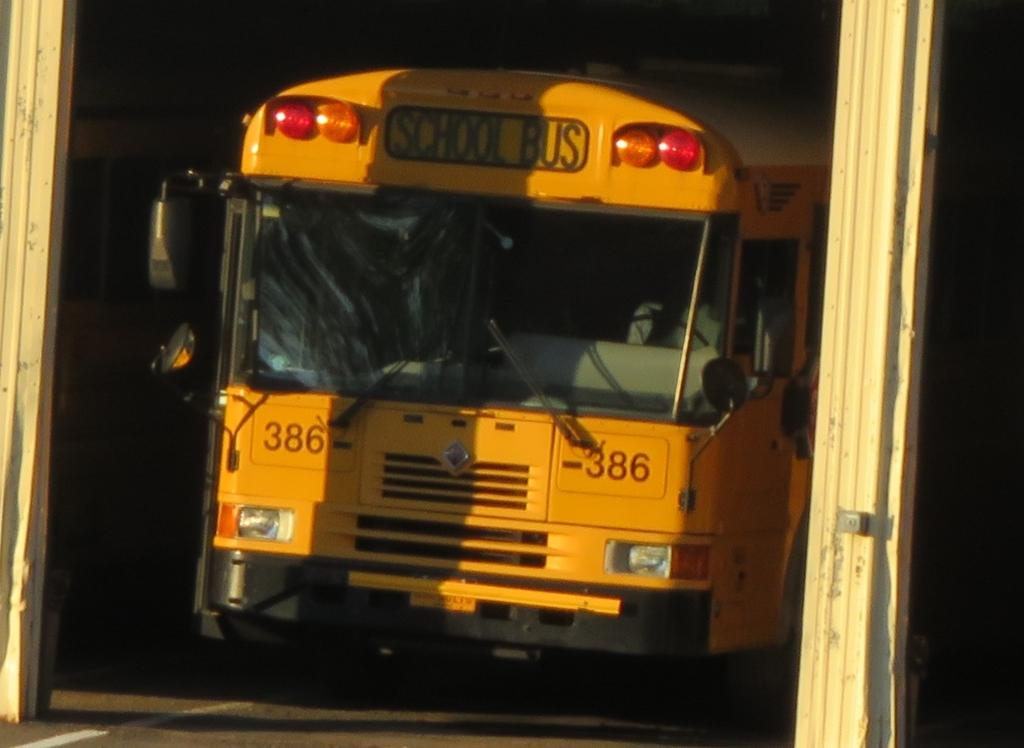What is the main subject of the image? The main subject of the image is a vehicle. What can be seen on either side of the vehicle? There are wooden poles on the right and left sides of the vehicle. How would you describe the background of the image? The background of the image is dark. How many snails can be seen crawling on the vehicle in the image? There are no snails visible on the vehicle in the image. What type of industry is depicted in the background of the image? There is no industry depicted in the image; the background is dark. 